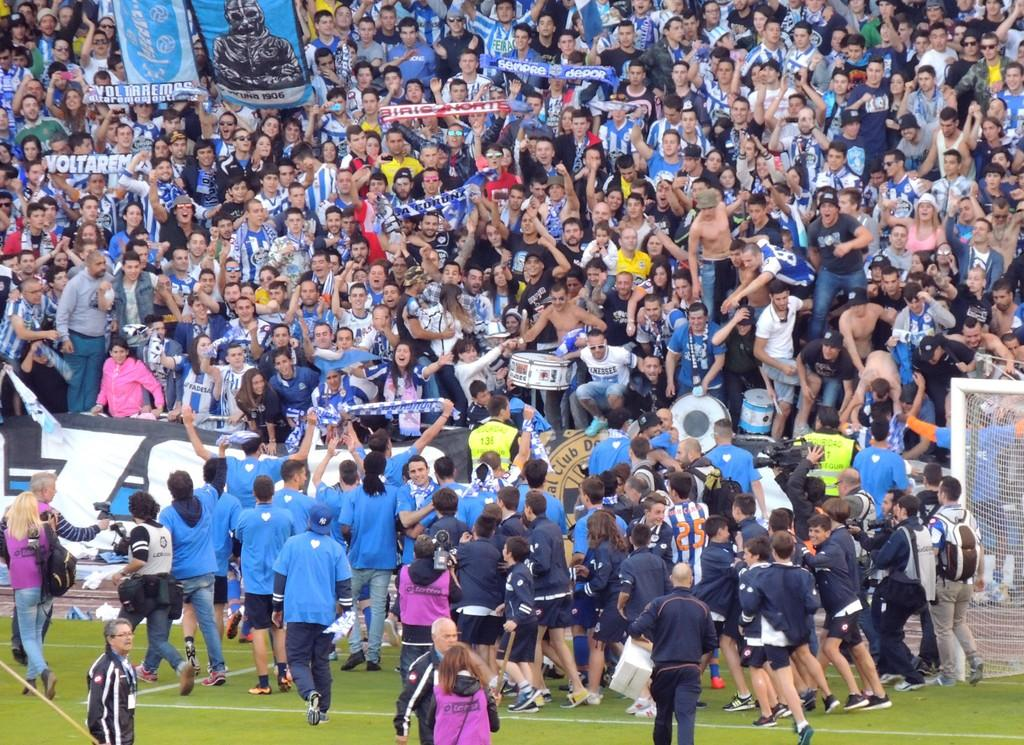<image>
Create a compact narrative representing the image presented. Group of people celebrating with one person holding a brown sign that says "Club". 